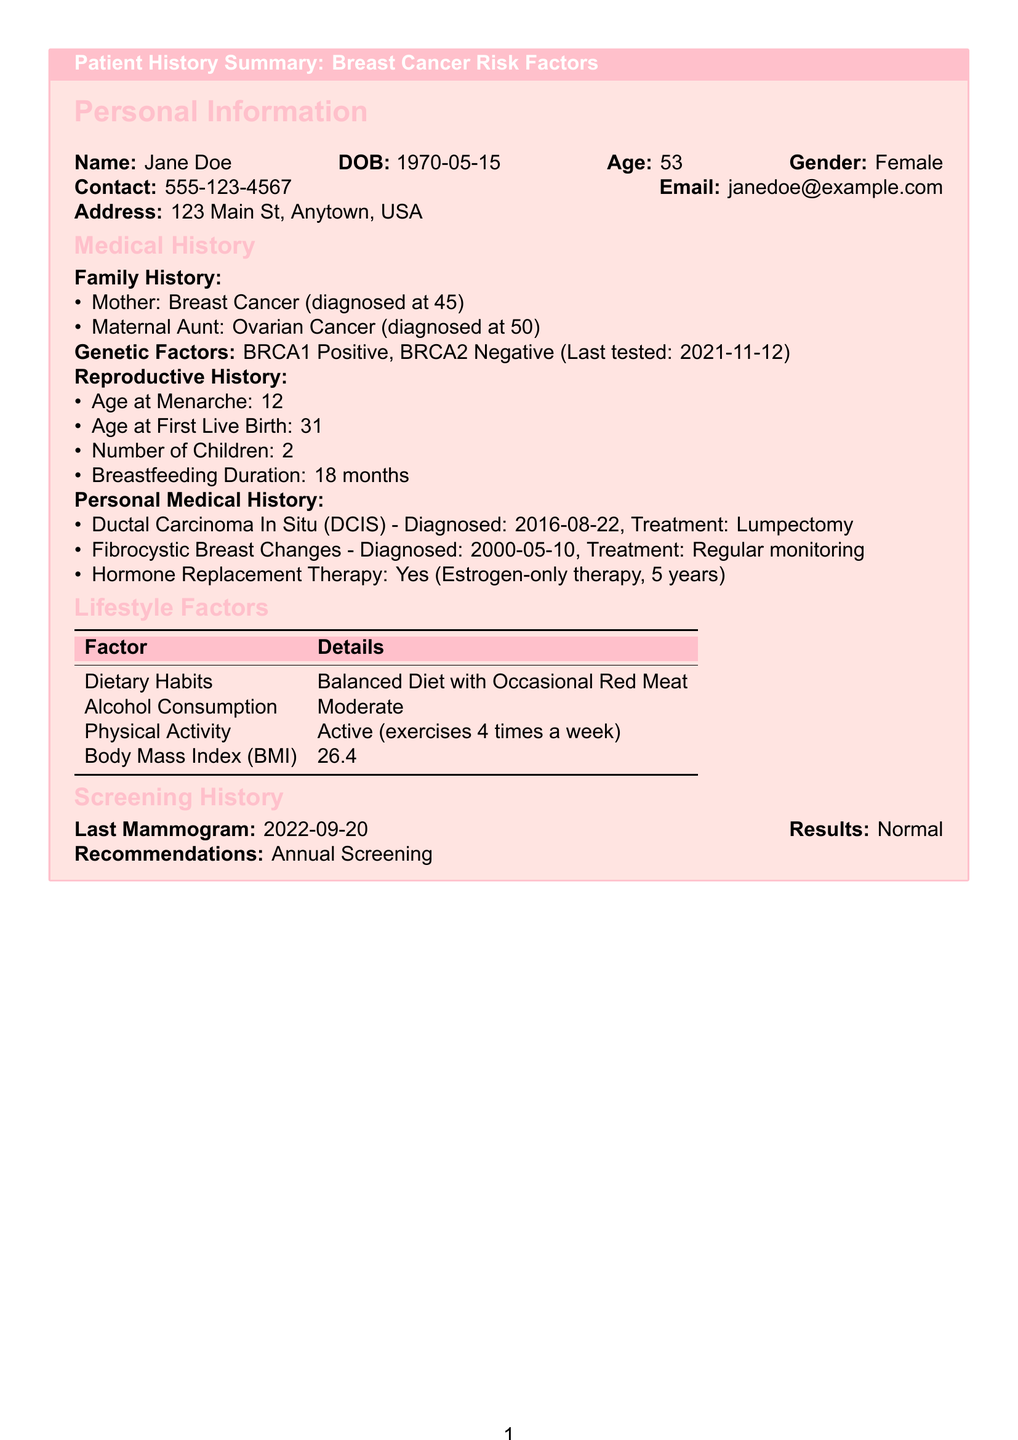What is the patient's name? The patient's name is listed at the beginning of the document under Personal Information.
Answer: Jane Doe What is the patient's Age? The patient's age can be calculated from the date of birth provided, which is stated in the document.
Answer: 53 What is the last date the patient was tested for genetic factors? The last tested date for genetic factors is mentioned in the Medical History section.
Answer: 2021-11-12 How many children does the patient have? The number of children the patient has is stated in the Reproductive History section.
Answer: 2 What type of Breast Cancer was diagnosed in 2016? The type of breast cancer diagnosed is specifically mentioned in the Personal Medical History section.
Answer: DCIS What screening recommendation does the patient have? The recommendation for screening is detailed in the Screening History section.
Answer: Annual Screening How many times a week does the patient exercise? The frequency of exercise is noted in the Lifestyle Factors section.
Answer: 4 times a week What is the patient's body mass index (BMI)? The BMI value is specified within the Lifestyle Factors tabular section.
Answer: 26.4 